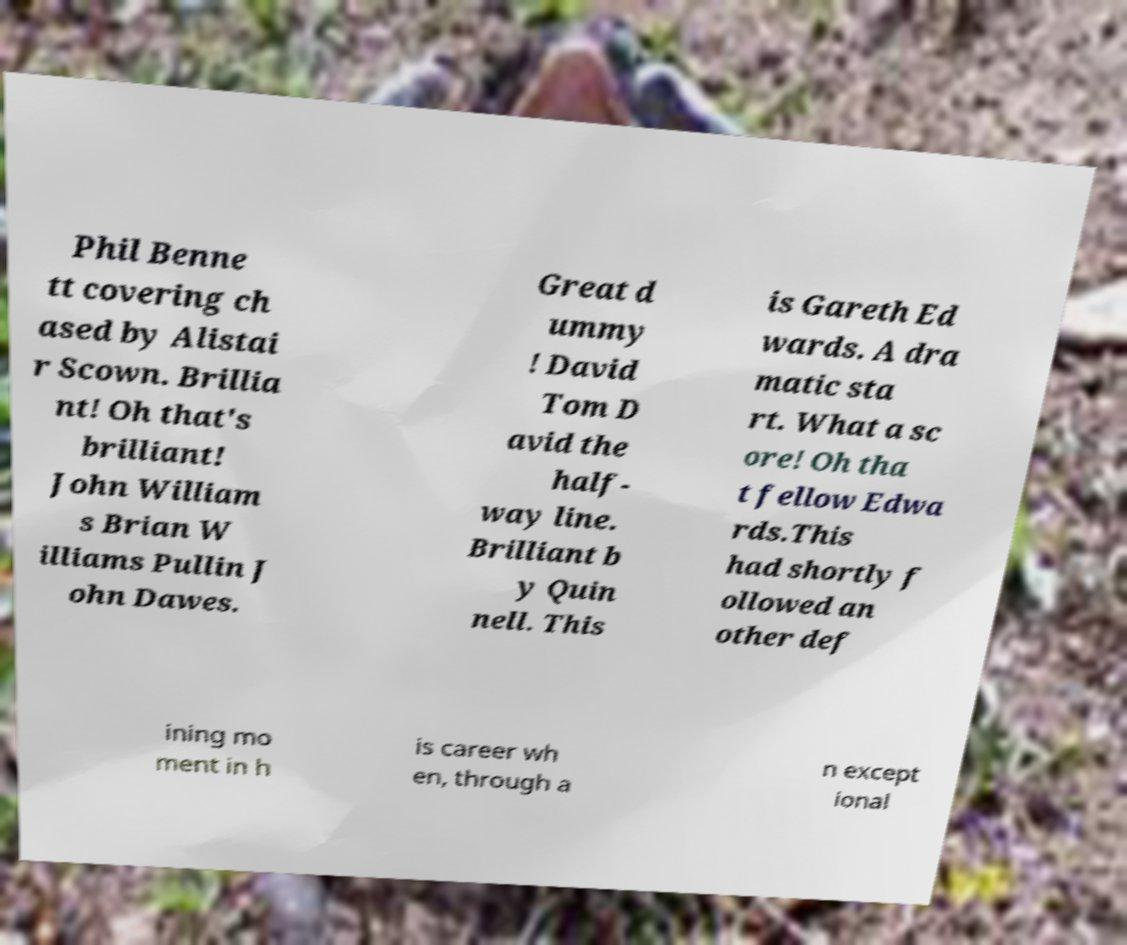There's text embedded in this image that I need extracted. Can you transcribe it verbatim? Phil Benne tt covering ch ased by Alistai r Scown. Brillia nt! Oh that's brilliant! John William s Brian W illiams Pullin J ohn Dawes. Great d ummy ! David Tom D avid the half- way line. Brilliant b y Quin nell. This is Gareth Ed wards. A dra matic sta rt. What a sc ore! Oh tha t fellow Edwa rds.This had shortly f ollowed an other def ining mo ment in h is career wh en, through a n except ional 